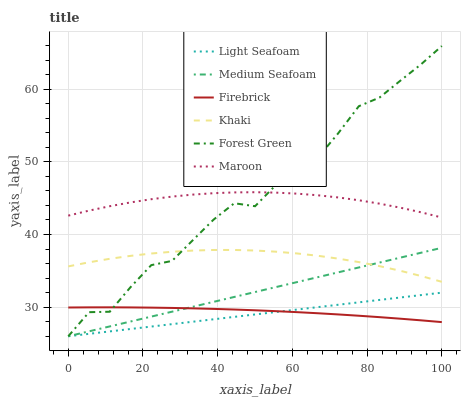Does Light Seafoam have the minimum area under the curve?
Answer yes or no. Yes. Does Forest Green have the maximum area under the curve?
Answer yes or no. Yes. Does Firebrick have the minimum area under the curve?
Answer yes or no. No. Does Firebrick have the maximum area under the curve?
Answer yes or no. No. Is Light Seafoam the smoothest?
Answer yes or no. Yes. Is Forest Green the roughest?
Answer yes or no. Yes. Is Firebrick the smoothest?
Answer yes or no. No. Is Firebrick the roughest?
Answer yes or no. No. Does Forest Green have the lowest value?
Answer yes or no. Yes. Does Firebrick have the lowest value?
Answer yes or no. No. Does Forest Green have the highest value?
Answer yes or no. Yes. Does Maroon have the highest value?
Answer yes or no. No. Is Light Seafoam less than Khaki?
Answer yes or no. Yes. Is Maroon greater than Light Seafoam?
Answer yes or no. Yes. Does Maroon intersect Forest Green?
Answer yes or no. Yes. Is Maroon less than Forest Green?
Answer yes or no. No. Is Maroon greater than Forest Green?
Answer yes or no. No. Does Light Seafoam intersect Khaki?
Answer yes or no. No. 